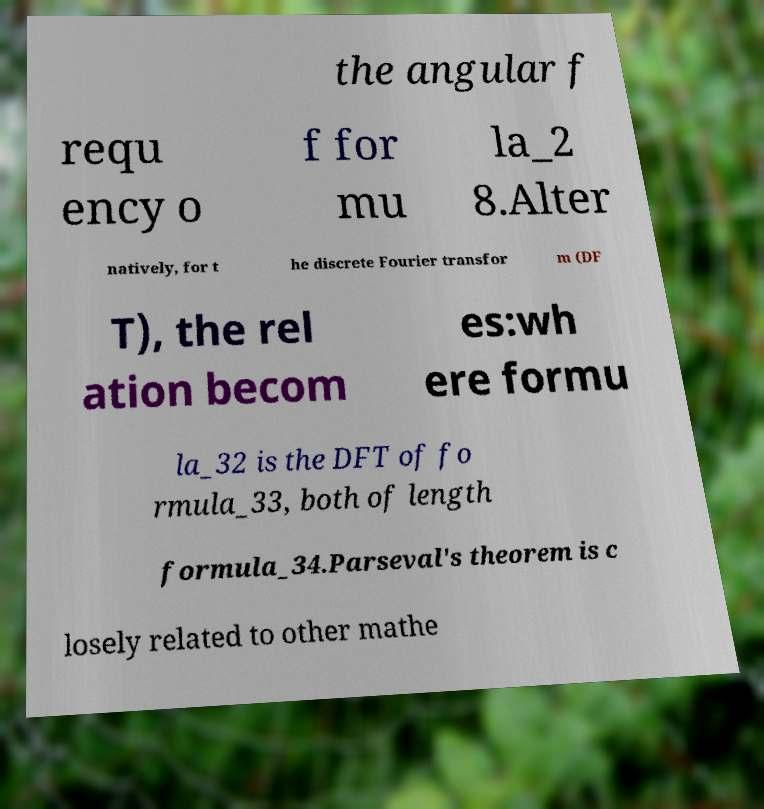Please identify and transcribe the text found in this image. the angular f requ ency o f for mu la_2 8.Alter natively, for t he discrete Fourier transfor m (DF T), the rel ation becom es:wh ere formu la_32 is the DFT of fo rmula_33, both of length formula_34.Parseval's theorem is c losely related to other mathe 